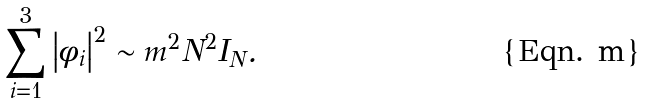Convert formula to latex. <formula><loc_0><loc_0><loc_500><loc_500>\sum _ { i = 1 } ^ { 3 } \left | \phi _ { i } \right | ^ { 2 } \sim m ^ { 2 } N ^ { 2 } I _ { N } .</formula> 